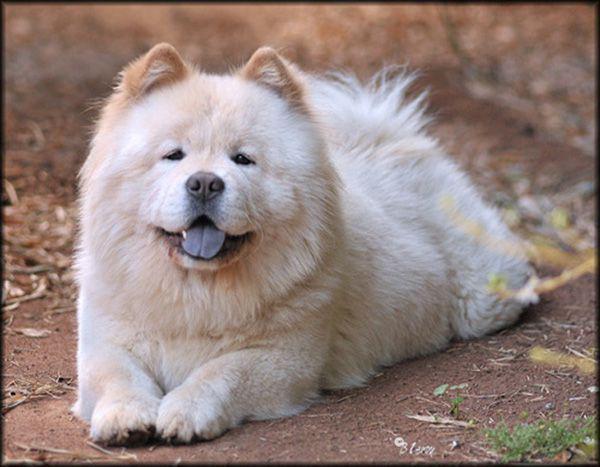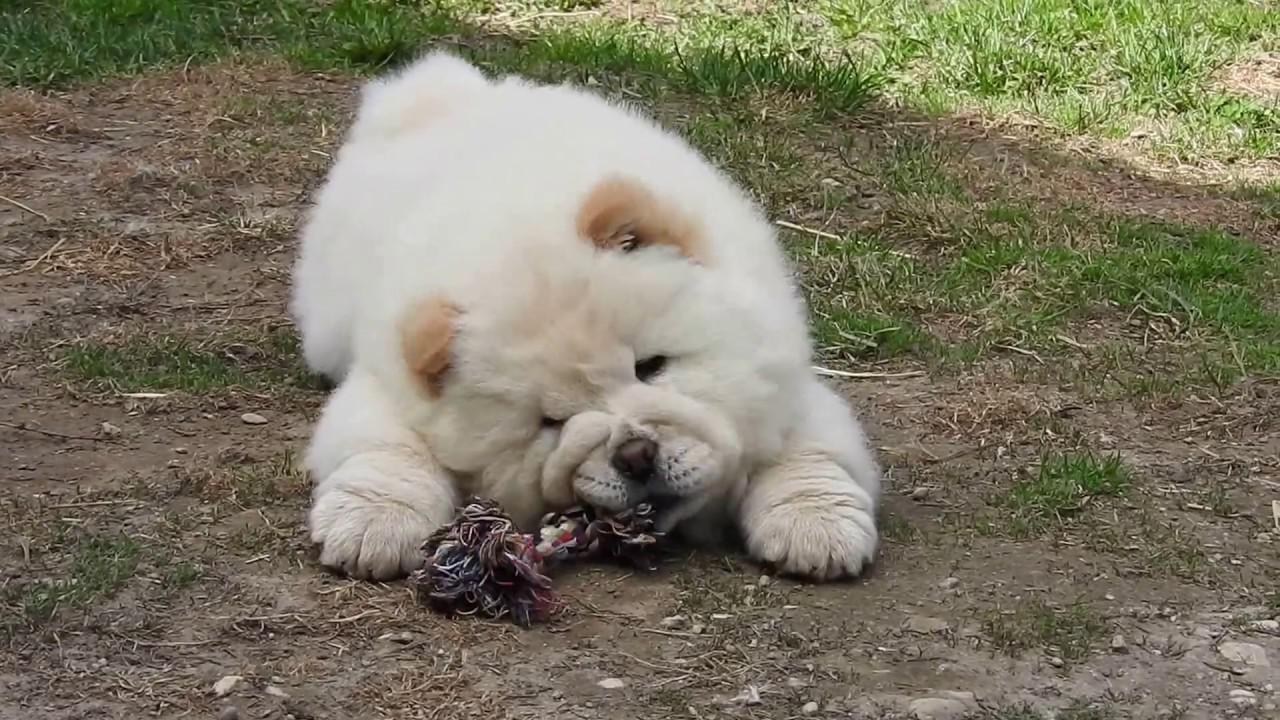The first image is the image on the left, the second image is the image on the right. Considering the images on both sides, is "In one image in each pair a dog is sleeping on a linoleum floor." valid? Answer yes or no. No. The first image is the image on the left, the second image is the image on the right. Examine the images to the left and right. Is the description "There is a toy visible in one of the images." accurate? Answer yes or no. Yes. 